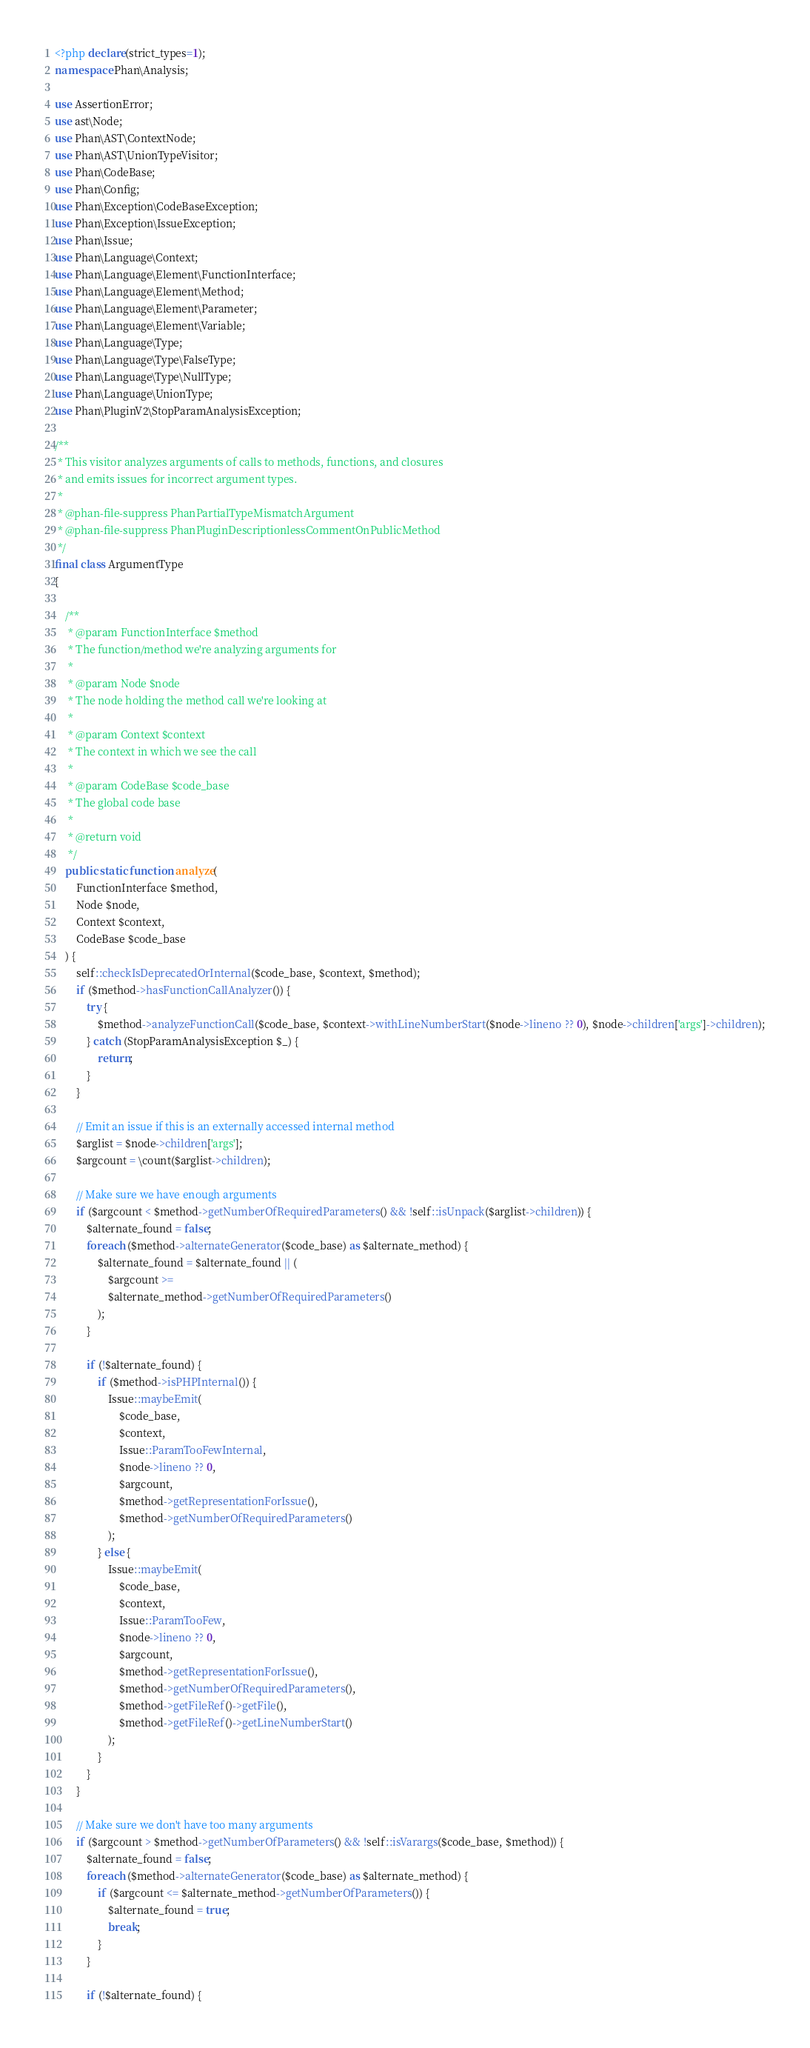Convert code to text. <code><loc_0><loc_0><loc_500><loc_500><_PHP_><?php declare(strict_types=1);
namespace Phan\Analysis;

use AssertionError;
use ast\Node;
use Phan\AST\ContextNode;
use Phan\AST\UnionTypeVisitor;
use Phan\CodeBase;
use Phan\Config;
use Phan\Exception\CodeBaseException;
use Phan\Exception\IssueException;
use Phan\Issue;
use Phan\Language\Context;
use Phan\Language\Element\FunctionInterface;
use Phan\Language\Element\Method;
use Phan\Language\Element\Parameter;
use Phan\Language\Element\Variable;
use Phan\Language\Type;
use Phan\Language\Type\FalseType;
use Phan\Language\Type\NullType;
use Phan\Language\UnionType;
use Phan\PluginV2\StopParamAnalysisException;

/**
 * This visitor analyzes arguments of calls to methods, functions, and closures
 * and emits issues for incorrect argument types.
 *
 * @phan-file-suppress PhanPartialTypeMismatchArgument
 * @phan-file-suppress PhanPluginDescriptionlessCommentOnPublicMethod
 */
final class ArgumentType
{

    /**
     * @param FunctionInterface $method
     * The function/method we're analyzing arguments for
     *
     * @param Node $node
     * The node holding the method call we're looking at
     *
     * @param Context $context
     * The context in which we see the call
     *
     * @param CodeBase $code_base
     * The global code base
     *
     * @return void
     */
    public static function analyze(
        FunctionInterface $method,
        Node $node,
        Context $context,
        CodeBase $code_base
    ) {
        self::checkIsDeprecatedOrInternal($code_base, $context, $method);
        if ($method->hasFunctionCallAnalyzer()) {
            try {
                $method->analyzeFunctionCall($code_base, $context->withLineNumberStart($node->lineno ?? 0), $node->children['args']->children);
            } catch (StopParamAnalysisException $_) {
                return;
            }
        }

        // Emit an issue if this is an externally accessed internal method
        $arglist = $node->children['args'];
        $argcount = \count($arglist->children);

        // Make sure we have enough arguments
        if ($argcount < $method->getNumberOfRequiredParameters() && !self::isUnpack($arglist->children)) {
            $alternate_found = false;
            foreach ($method->alternateGenerator($code_base) as $alternate_method) {
                $alternate_found = $alternate_found || (
                    $argcount >=
                    $alternate_method->getNumberOfRequiredParameters()
                );
            }

            if (!$alternate_found) {
                if ($method->isPHPInternal()) {
                    Issue::maybeEmit(
                        $code_base,
                        $context,
                        Issue::ParamTooFewInternal,
                        $node->lineno ?? 0,
                        $argcount,
                        $method->getRepresentationForIssue(),
                        $method->getNumberOfRequiredParameters()
                    );
                } else {
                    Issue::maybeEmit(
                        $code_base,
                        $context,
                        Issue::ParamTooFew,
                        $node->lineno ?? 0,
                        $argcount,
                        $method->getRepresentationForIssue(),
                        $method->getNumberOfRequiredParameters(),
                        $method->getFileRef()->getFile(),
                        $method->getFileRef()->getLineNumberStart()
                    );
                }
            }
        }

        // Make sure we don't have too many arguments
        if ($argcount > $method->getNumberOfParameters() && !self::isVarargs($code_base, $method)) {
            $alternate_found = false;
            foreach ($method->alternateGenerator($code_base) as $alternate_method) {
                if ($argcount <= $alternate_method->getNumberOfParameters()) {
                    $alternate_found = true;
                    break;
                }
            }

            if (!$alternate_found) {</code> 